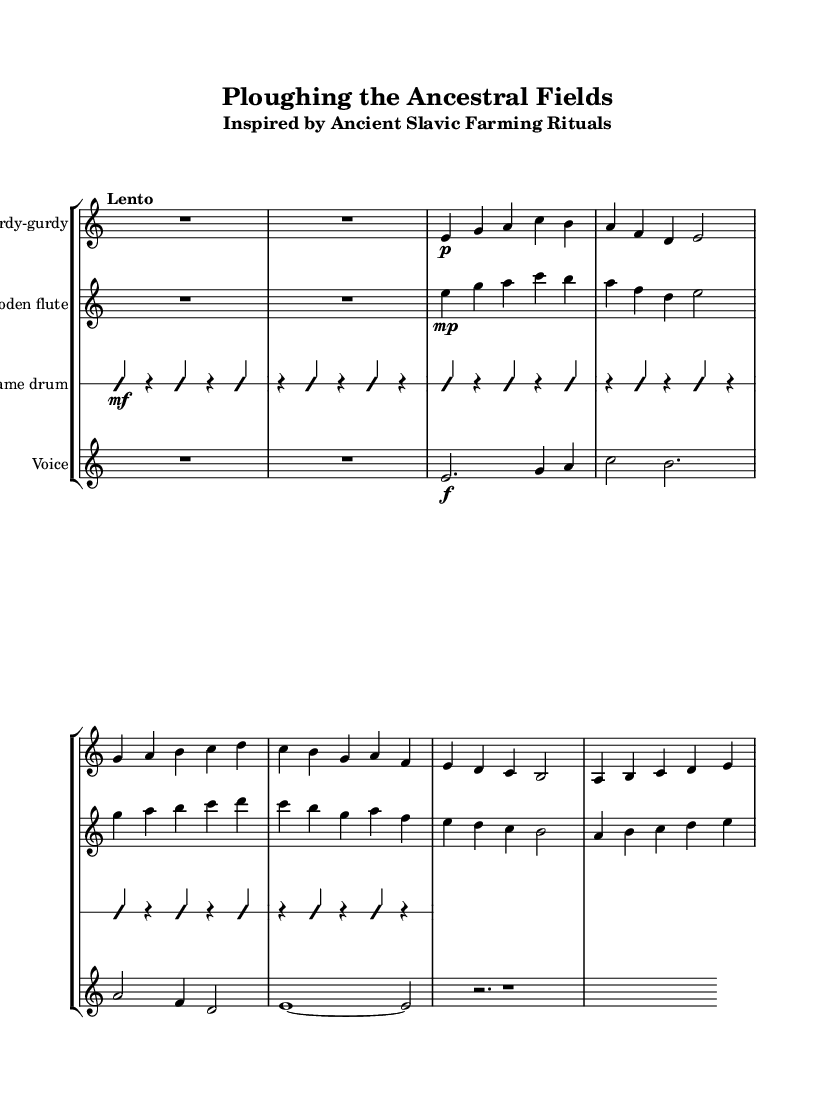What is the time signature of this music? The time signature is indicated at the beginning of the score as 5/4, which means there are five beats in each measure.
Answer: 5/4 What is the tempo marking of this piece? The tempo marking is written as "Lento," which indicates a slow tempo for the performance.
Answer: Lento Which instruments are used in this composition? The instrument names are listed at the start of each staff: Hurdy-gurdy, Wooden flute, Frame drum, and Voice.
Answer: Hurdy-gurdy, Wooden flute, Frame drum, Voice How many staves are present in the score? The score contains four staves, one for each instrument mentioned: Hurdy-gurdy, Wooden flute, Frame drum, and Voice.
Answer: Four What dynamic marking is given to the voice part at the start? The voice part starts with a dynamic marking of forte, indicated by the symbol "f."
Answer: Forte What kind of rhythmic technique is indicated for the frame drum part? The frame drum part is marked as "improvisationOn," suggesting that the player is encouraged to improvise their rhythm.
Answer: Improvisation 